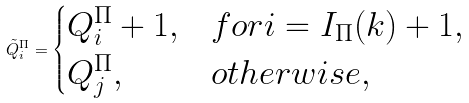<formula> <loc_0><loc_0><loc_500><loc_500>\tilde { Q } ^ { \Pi } _ { i } = \begin{cases} Q ^ { \Pi } _ { i } + 1 , & f o r i = I _ { \Pi } ( k ) + 1 , \\ Q ^ { \Pi } _ { j } , & o t h e r w i s e , \end{cases}</formula> 